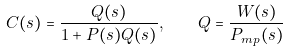<formula> <loc_0><loc_0><loc_500><loc_500>C ( s ) = \frac { Q ( s ) } { 1 + P ( s ) Q ( s ) } , \quad Q = \frac { W ( s ) } { P _ { m p } ( s ) }</formula> 